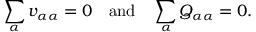<formula> <loc_0><loc_0><loc_500><loc_500>\sum _ { \alpha } v _ { \alpha \alpha } = 0 \quad a n d \quad \sum _ { \alpha } Q _ { \alpha \alpha } = 0 .</formula> 